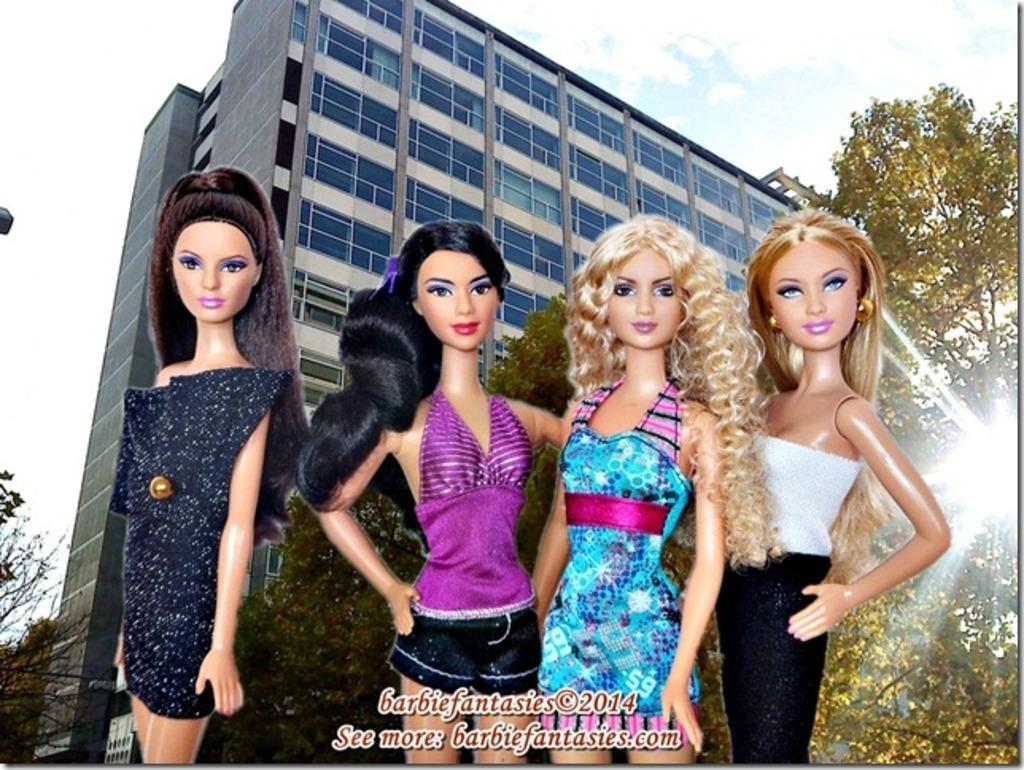What type of images are present in the image? There are cartoon images in the image. What structure can be seen in the image? There is a building in the image. What architectural feature is visible on the building? There are windows in the image. What type of natural elements are present in the image? There are trees in the image. What part of the natural environment is visible in the image? The sky is visible in the image. What additional information is provided on the image? There is text on the image. What is the wind speed in the image? There is no information about wind speed in the image. What is the size of the trees in the image? The size of the trees cannot be determined from the image alone. 